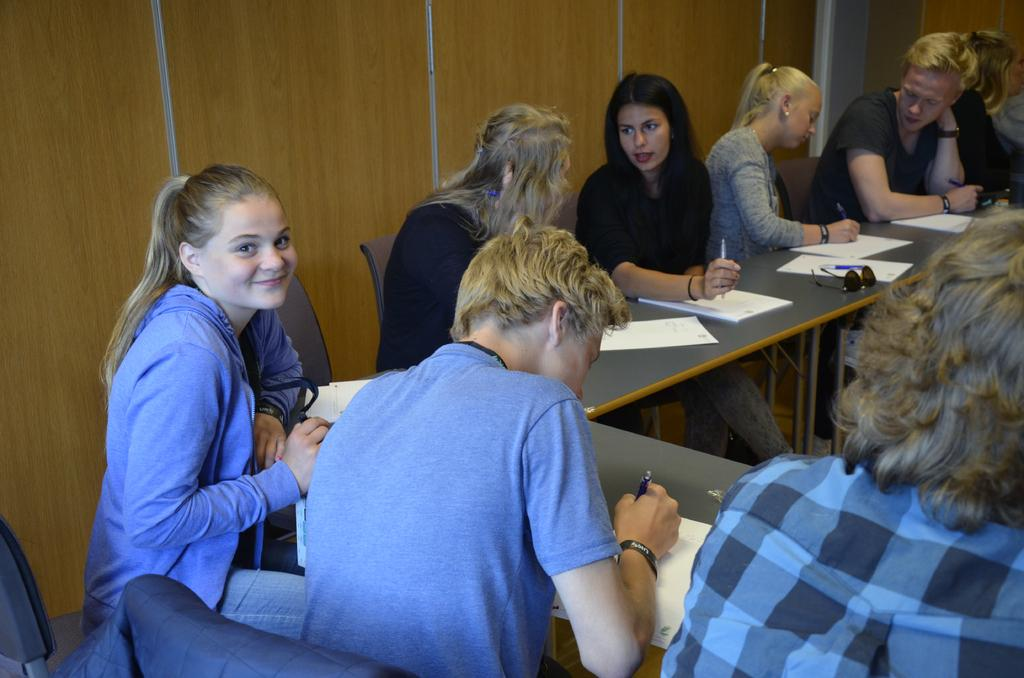What are the people in the image doing? The people in the image are sitting on chairs. What is in front of the people? There is a table in front of the people. What is on the table? There are books on the table. What action are the people performing with the pens? The people are catching pens with their hands. What type of respect can be seen on the people's toes in the image? There is no mention of respect or toes in the image; the people are catching pens with their hands. 